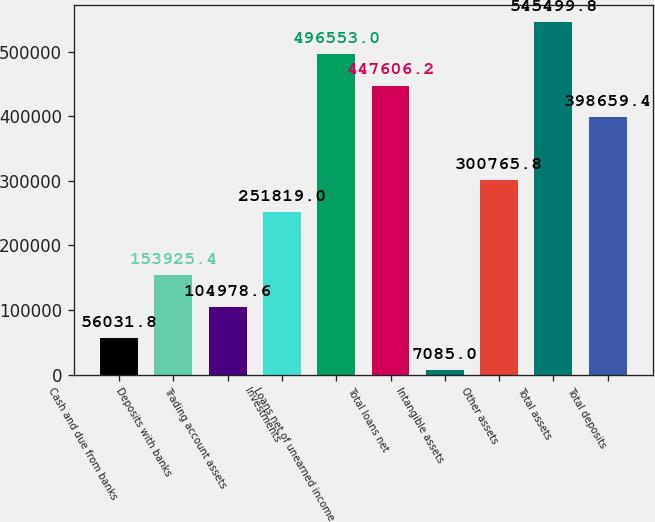<chart> <loc_0><loc_0><loc_500><loc_500><bar_chart><fcel>Cash and due from banks<fcel>Deposits with banks<fcel>Trading account assets<fcel>Investments<fcel>Loans net of unearned income<fcel>Total loans net<fcel>Intangible assets<fcel>Other assets<fcel>Total assets<fcel>Total deposits<nl><fcel>56031.8<fcel>153925<fcel>104979<fcel>251819<fcel>496553<fcel>447606<fcel>7085<fcel>300766<fcel>545500<fcel>398659<nl></chart> 